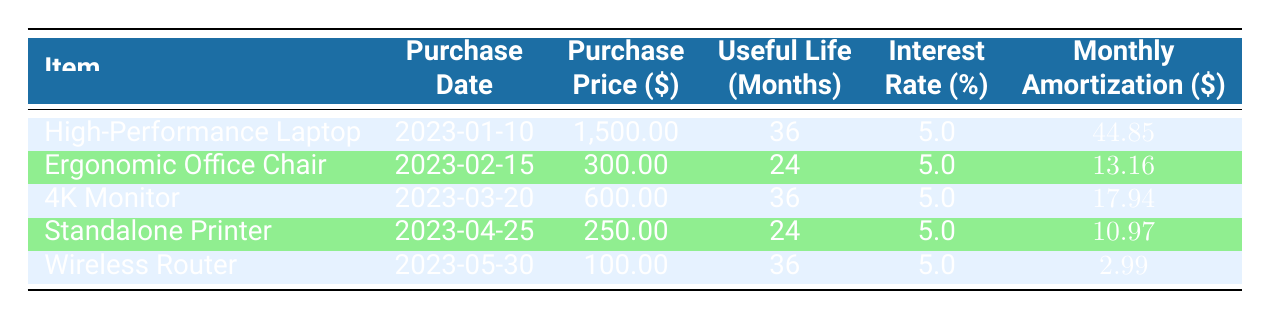What is the purchase price of the High-Performance Laptop? The purchase price for the High-Performance Laptop is listed in the "Purchase Price (\$)" column under the row for that item, which shows 1,500.00.
Answer: 1,500.00 What is the useful life of the Ergonomic Office Chair? The useful life of the Ergonomic Office Chair can be found in the "Useful Life (Months)" column corresponding to that item. It shows 24 months.
Answer: 24 months What is the total monthly amortization for all items? To find the total monthly amortization, sum the monthly amortization amounts from each row: 44.85 + 13.16 + 17.94 + 10.97 + 2.99 = 89.91.
Answer: 89.91 Does the Wireless Router have a longer useful life than the Ergonomic Office Chair? The useful life of the Wireless Router is 36 months, while the Ergonomic Office Chair has a useful life of 24 months. Since 36 months is greater than 24 months, the statement is true.
Answer: Yes What is the average monthly amortization across all items? To find the average, sum the monthly amortization amounts: 44.85 + 13.16 + 17.94 + 10.97 + 2.99 = 89.91. There are 5 items, so divide the total by 5: 89.91 / 5 = 17.982.
Answer: 17.98 